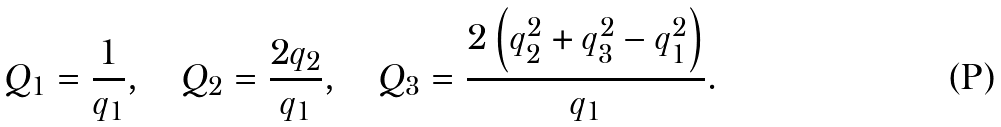Convert formula to latex. <formula><loc_0><loc_0><loc_500><loc_500>Q _ { 1 } = \frac { 1 } { q _ { 1 } } , \quad Q _ { 2 } = \frac { 2 q _ { 2 } } { q _ { 1 } } , \quad Q _ { 3 } = \frac { 2 \left ( q _ { 2 } ^ { 2 } + q _ { 3 } ^ { 2 } - q _ { 1 } ^ { 2 } \right ) } { q _ { 1 } } .</formula> 